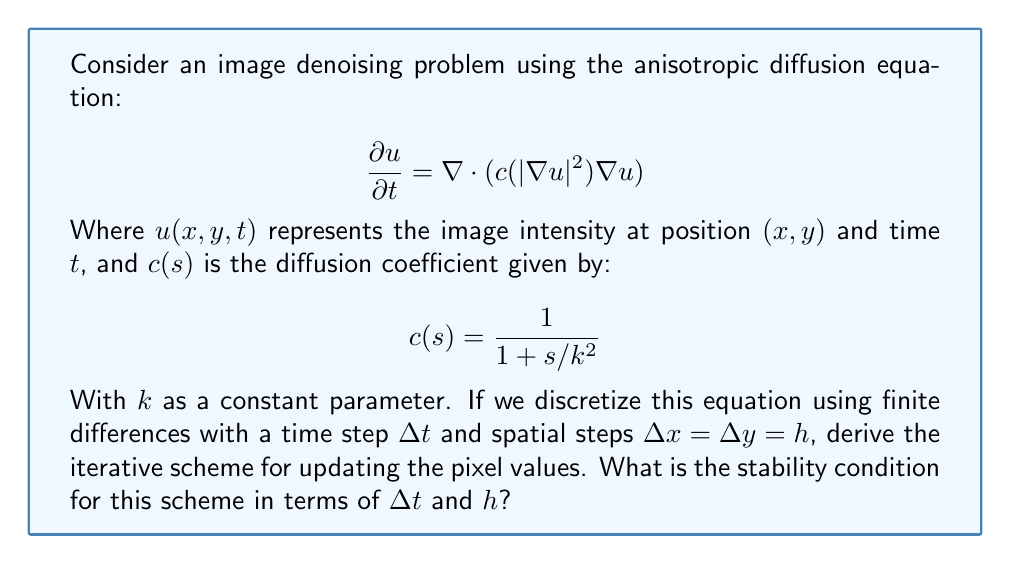Can you answer this question? To solve this problem, we'll follow these steps:

1) Discretize the anisotropic diffusion equation using finite differences.
2) Derive the iterative scheme for updating pixel values.
3) Determine the stability condition.

Step 1: Discretization

Let's denote $u_{i,j}^n$ as the value of $u$ at pixel $(i,j)$ at time step $n$. We'll use central differences for spatial derivatives and forward difference for the time derivative:

$$\frac{\partial u}{\partial t} \approx \frac{u_{i,j}^{n+1} - u_{i,j}^n}{\Delta t}$$

$$\nabla u \approx \left(\frac{u_{i+1,j}^n - u_{i-1,j}^n}{2h}, \frac{u_{i,j+1}^n - u_{i,j-1}^n}{2h}\right)$$

$$|\nabla u|^2 \approx \frac{(u_{i+1,j}^n - u_{i-1,j}^n)^2 + (u_{i,j+1}^n - u_{i,j-1}^n)^2}{4h^2}$$

Step 2: Iterative Scheme

Substituting these approximations into the original equation:

$$\frac{u_{i,j}^{n+1} - u_{i,j}^n}{\Delta t} = \frac{1}{h^2}\left[c_{i+\frac{1}{2},j}^n(u_{i+1,j}^n - u_{i,j}^n) - c_{i-\frac{1}{2},j}^n(u_{i,j}^n - u_{i-1,j}^n) + c_{i,j+\frac{1}{2}}^n(u_{i,j+1}^n - u_{i,j}^n) - c_{i,j-\frac{1}{2}}^n(u_{i,j}^n - u_{i,j-1}^n)\right]$$

Where $c_{i+\frac{1}{2},j}^n$, $c_{i-\frac{1}{2},j}^n$, $c_{i,j+\frac{1}{2}}^n$, and $c_{i,j-\frac{1}{2}}^n$ are the diffusion coefficients at the interfaces between pixels.

Rearranging this equation gives us the iterative scheme:

$$u_{i,j}^{n+1} = u_{i,j}^n + \frac{\Delta t}{h^2}\left[c_{i+\frac{1}{2},j}^n(u_{i+1,j}^n - u_{i,j}^n) - c_{i-\frac{1}{2},j}^n(u_{i,j}^n - u_{i-1,j}^n) + c_{i,j+\frac{1}{2}}^n(u_{i,j+1}^n - u_{i,j}^n) - c_{i,j-\frac{1}{2}}^n(u_{i,j}^n - u_{i,j-1}^n)\right]$$

Step 3: Stability Condition

For stability, we need the coefficient of $u_{i,j}^n$ to be non-negative when we collect terms. The coefficient is:

$$1 - \frac{\Delta t}{h^2}(c_{i+\frac{1}{2},j}^n + c_{i-\frac{1}{2},j}^n + c_{i,j+\frac{1}{2}}^n + c_{i,j-\frac{1}{2}}^n)$$

Since $0 \leq c(s) \leq 1$ for all $s$, the worst case is when all $c$ values are 1. Therefore, for stability:

$$1 - \frac{4\Delta t}{h^2} \geq 0$$

This gives us the stability condition:

$$\Delta t \leq \frac{h^2}{4}$$
Answer: $\Delta t \leq \frac{h^2}{4}$ 